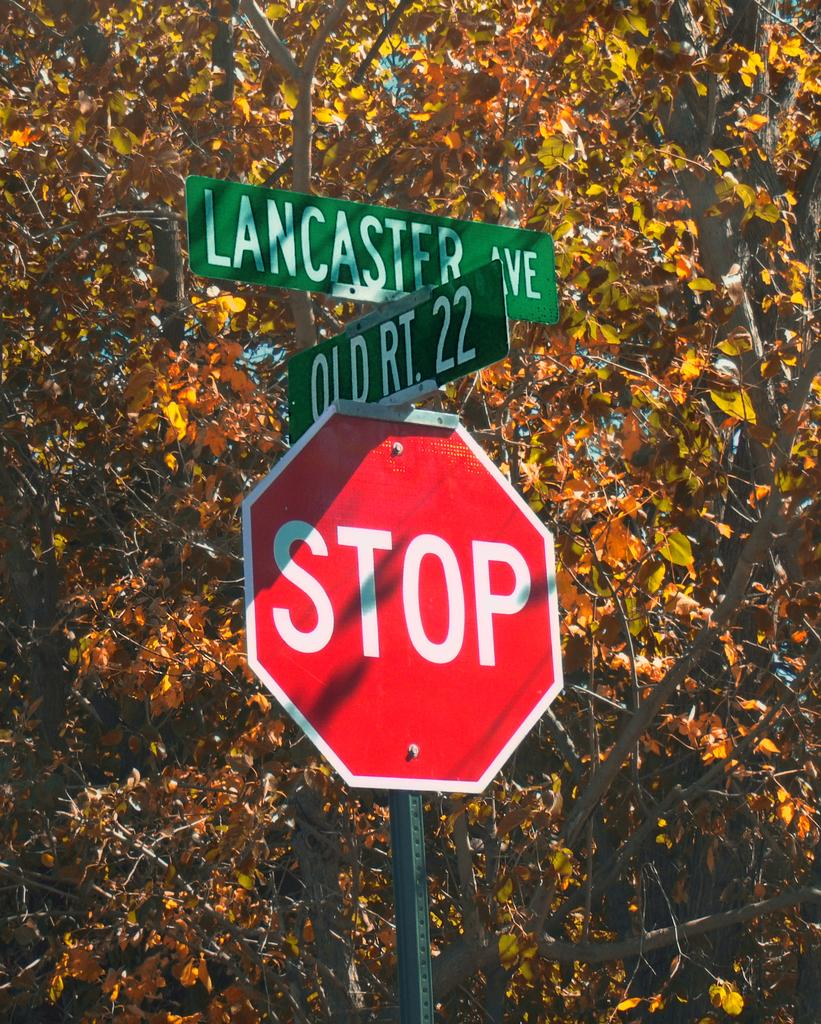<image>
Describe the image concisely. A red stop sign with signs for Old Rt 22 and Lancaster Ave above it. 